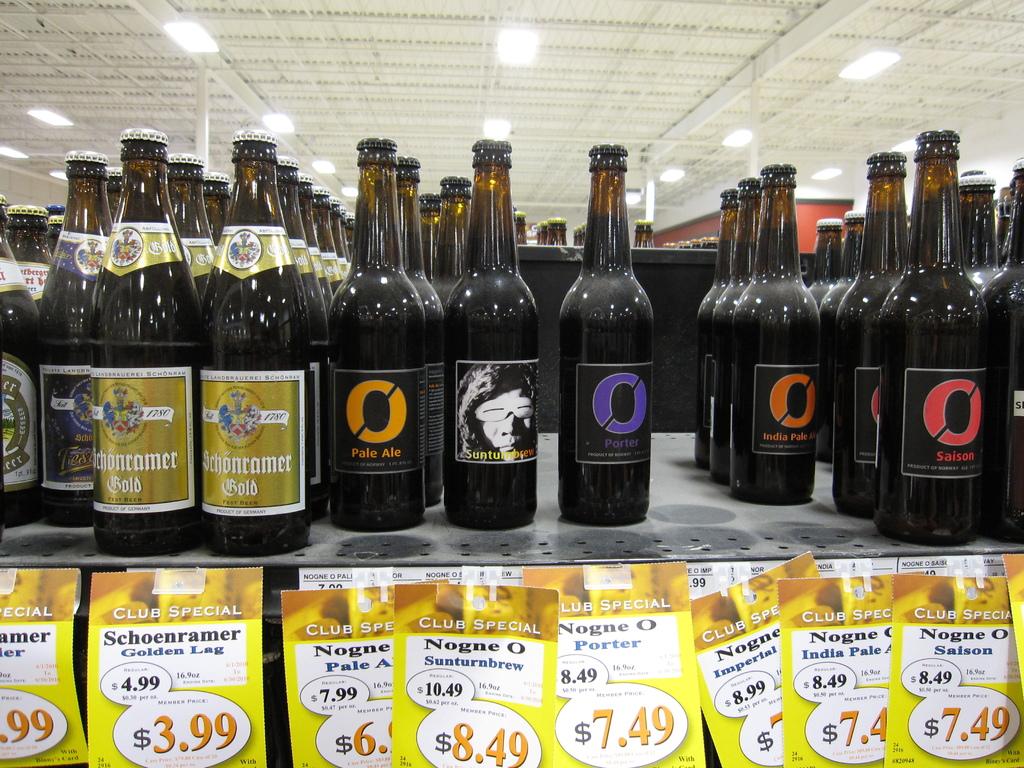What is the price of the bottles with a gold label?
Your response must be concise. 3.99. 